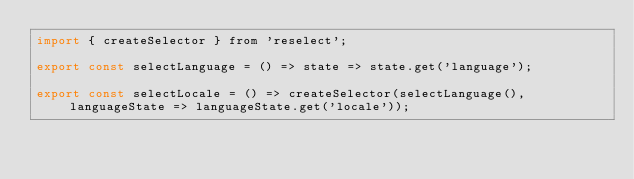<code> <loc_0><loc_0><loc_500><loc_500><_JavaScript_>import { createSelector } from 'reselect';

export const selectLanguage = () => state => state.get('language');

export const selectLocale = () => createSelector(selectLanguage(), languageState => languageState.get('locale'));
</code> 